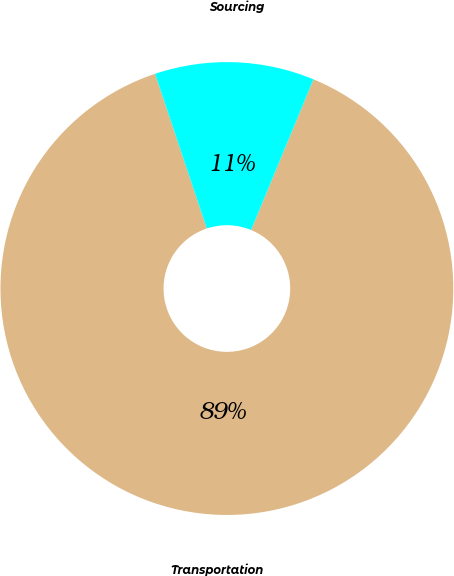Convert chart. <chart><loc_0><loc_0><loc_500><loc_500><pie_chart><fcel>Transportation<fcel>Sourcing<nl><fcel>88.62%<fcel>11.38%<nl></chart> 